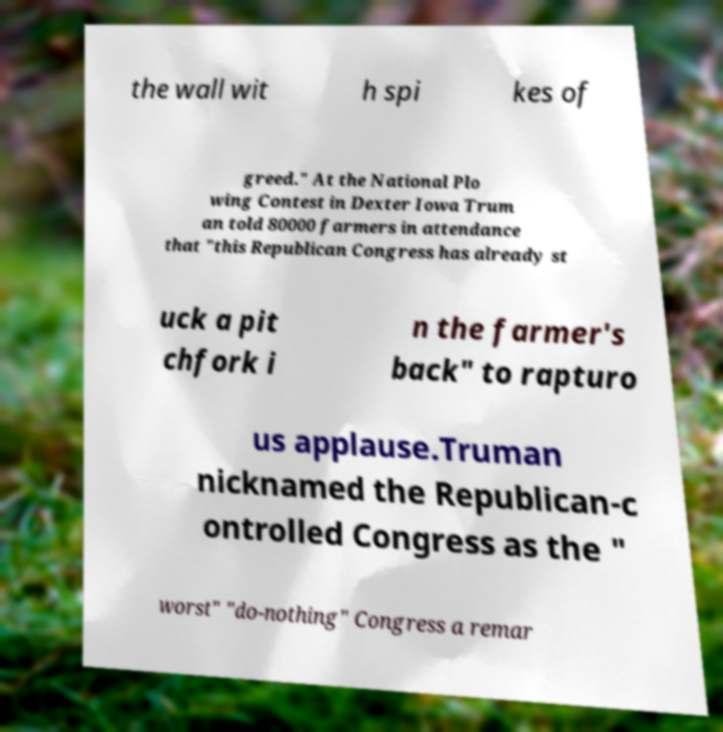Can you accurately transcribe the text from the provided image for me? the wall wit h spi kes of greed." At the National Plo wing Contest in Dexter Iowa Trum an told 80000 farmers in attendance that "this Republican Congress has already st uck a pit chfork i n the farmer's back" to rapturo us applause.Truman nicknamed the Republican-c ontrolled Congress as the " worst" "do-nothing" Congress a remar 